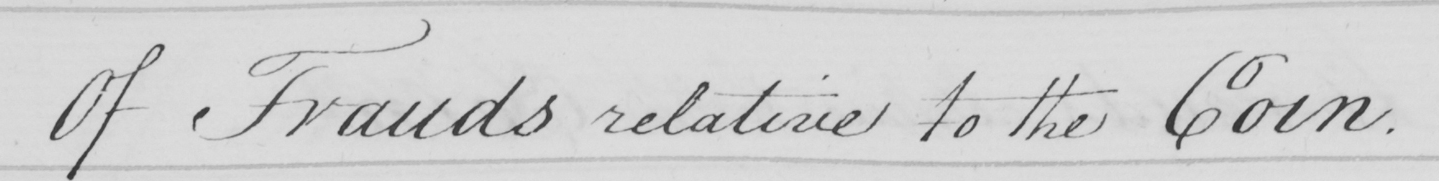Transcribe the text shown in this historical manuscript line. Of Frauds relative to the Coin . 